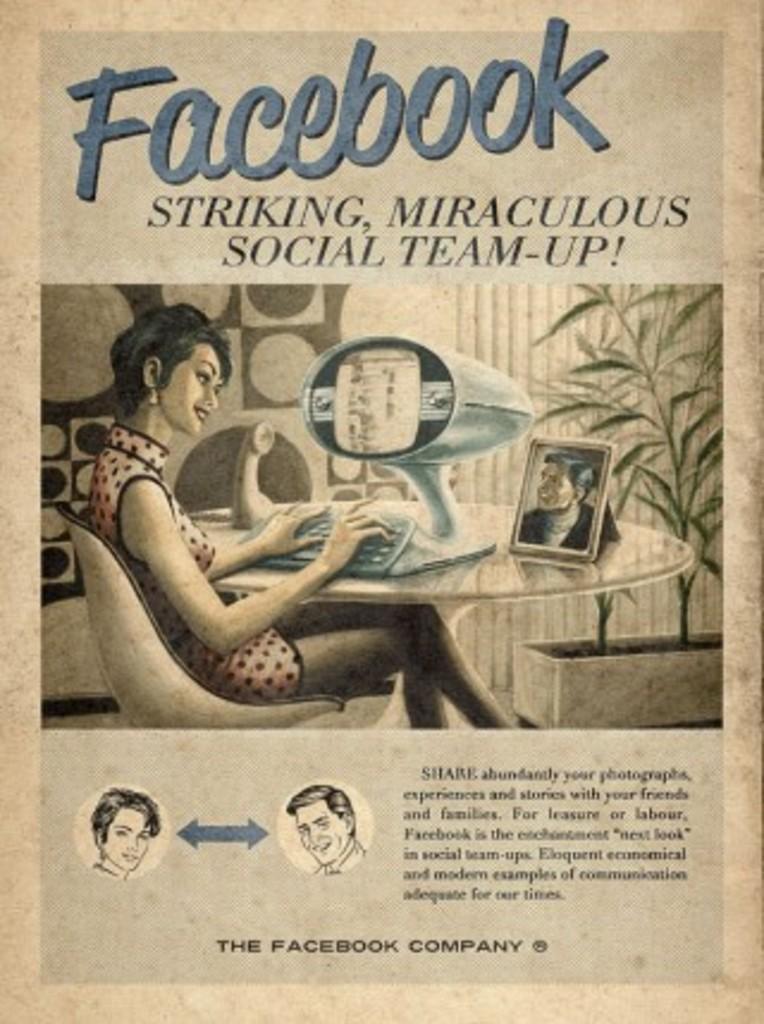How would you summarize this image in a sentence or two? In the center of the image we can see one poster. On the poster, we can see one woman sitting on a chair and holding some object. In front of her, there is a table. On the table, we can see one keyboard, monitor, photo frame and a few other objects. In the background there is a wall, curtain and plants. And we can see some text and two human faces on the poster. 